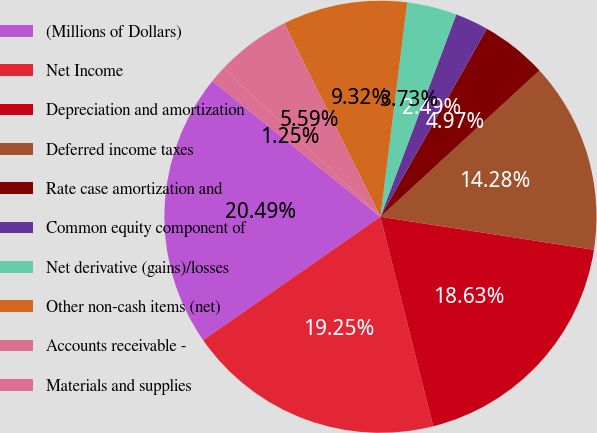<chart> <loc_0><loc_0><loc_500><loc_500><pie_chart><fcel>(Millions of Dollars)<fcel>Net Income<fcel>Depreciation and amortization<fcel>Deferred income taxes<fcel>Rate case amortization and<fcel>Common equity component of<fcel>Net derivative (gains)/losses<fcel>Other non-cash items (net)<fcel>Accounts receivable -<fcel>Materials and supplies<nl><fcel>20.49%<fcel>19.25%<fcel>18.63%<fcel>14.28%<fcel>4.97%<fcel>2.49%<fcel>3.73%<fcel>9.32%<fcel>5.59%<fcel>1.25%<nl></chart> 